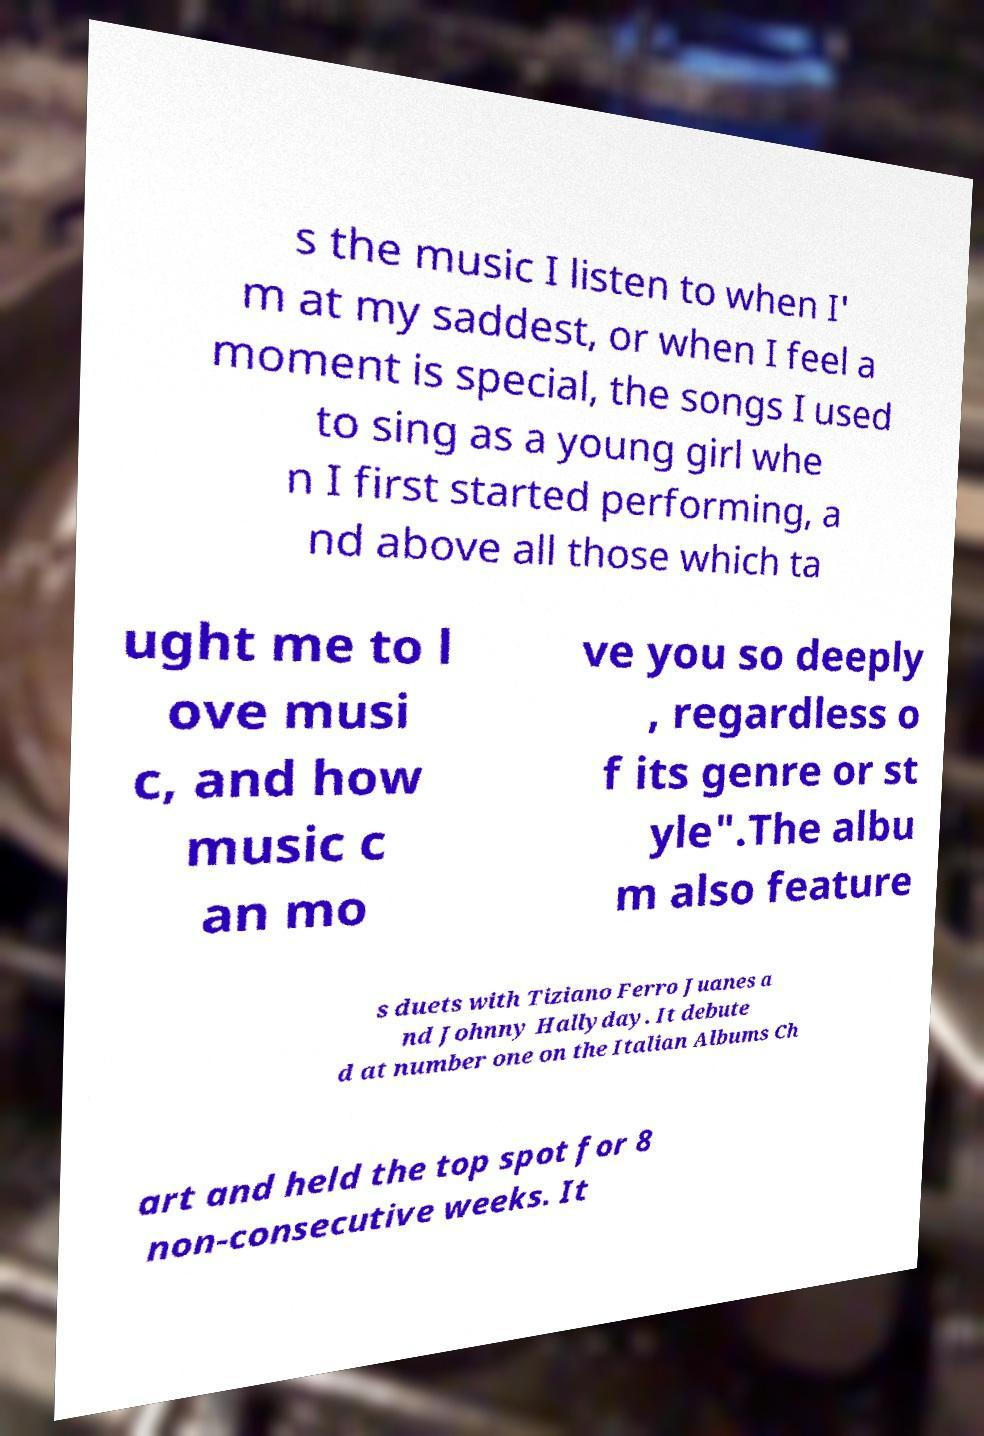Can you accurately transcribe the text from the provided image for me? s the music I listen to when I' m at my saddest, or when I feel a moment is special, the songs I used to sing as a young girl whe n I first started performing, a nd above all those which ta ught me to l ove musi c, and how music c an mo ve you so deeply , regardless o f its genre or st yle".The albu m also feature s duets with Tiziano Ferro Juanes a nd Johnny Hallyday. It debute d at number one on the Italian Albums Ch art and held the top spot for 8 non-consecutive weeks. It 